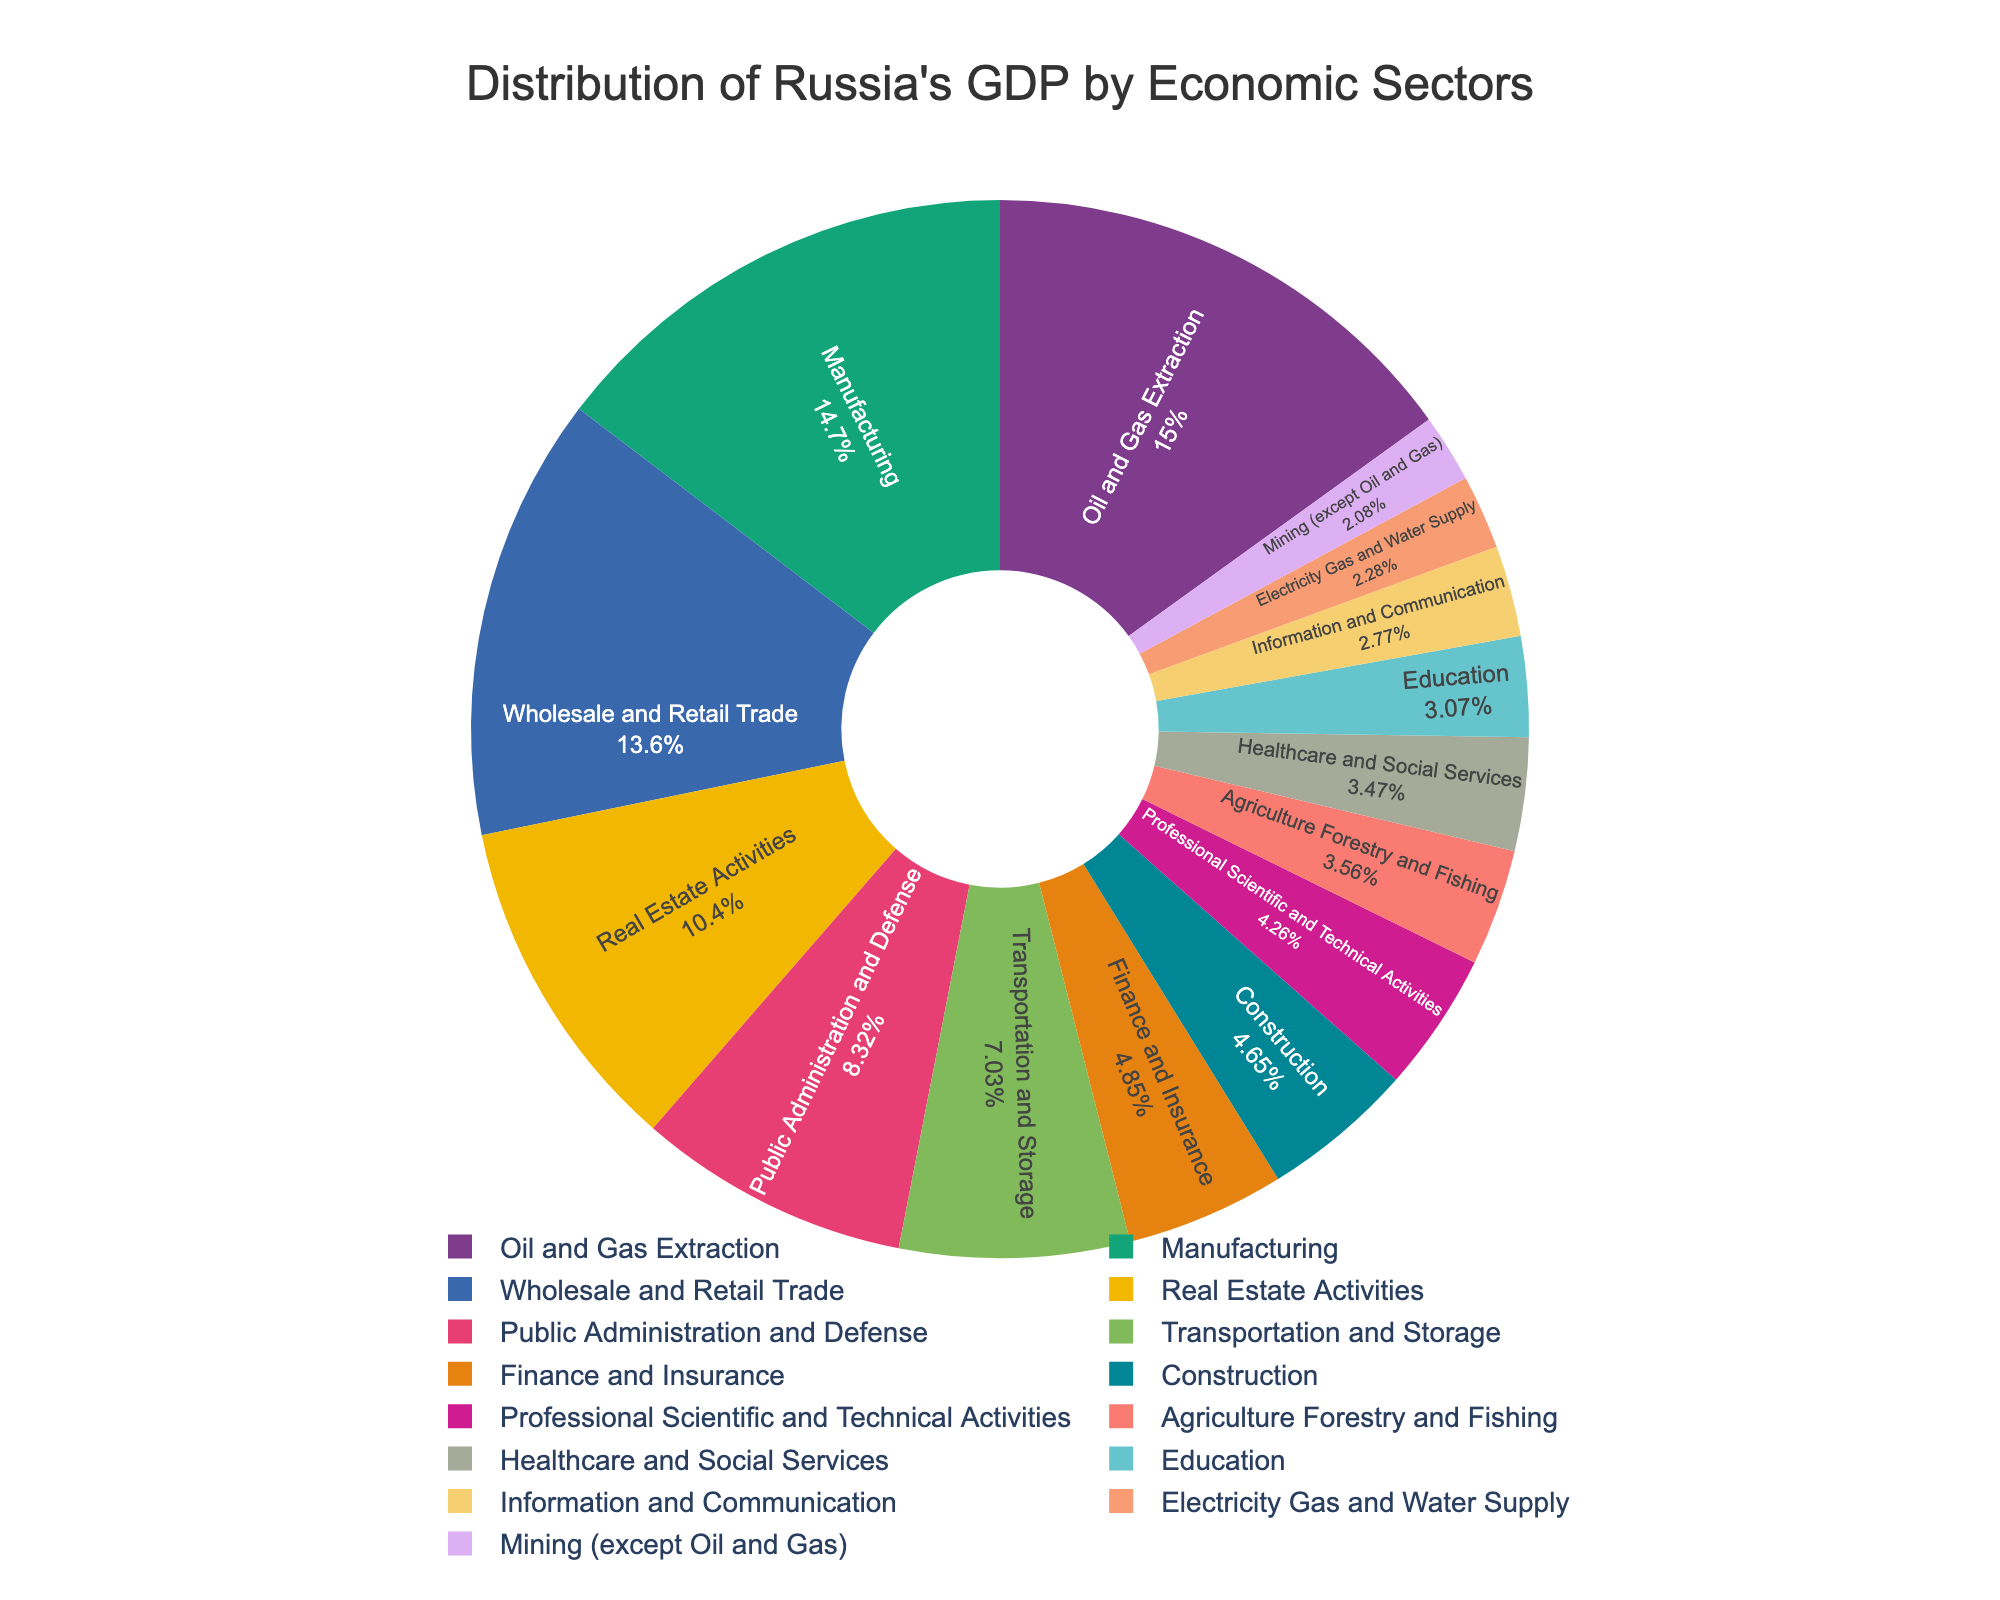Which economic sector has the largest contribution to Russia's GDP? The largest segment in the pie chart represents the sector with the highest percentage. In this case, Oil and Gas Extraction is 15.2%, the highest.
Answer: Oil and Gas Extraction Which two sectors together contribute approximately 28.9% to Russia's GDP? Adding the individual contributions of Manufacturing (14.8%) and Wholesale and Retail Trade (13.7%) results in approximately 28.5%.
Answer: Manufacturing and Wholesale and Retail Trade How much more does Oil and Gas Extraction contribute to GDP compared to Professional Scientific and Technical Activities? Subtract the contribution of Professional Scientific and Technical Activities (4.3%) from the contribution of Oil and Gas Extraction (15.2%): 15.2% - 4.3% = 10.9%.
Answer: 10.9% If you were to combine the contributions of Healthcare and Social Services and Agriculture Forestry and Fishing, how would they compare to the contribution of Real Estate Activities? Add the contributions of Healthcare and Social Services (3.5%) and Agriculture Forestry and Fishing (3.6%), which equals 7.1%, and compare it to Real Estate Activities (10.5%). 7.1% < 10.5%.
Answer: Less than Real Estate Activities Rank the top three sectors in terms of their contribution to Russia’s GDP. By descending order of percentage, the top three sectors are: 1. Oil and Gas Extraction (15.2%), 2. Manufacturing (14.8%), and 3. Wholesale and Retail Trade (13.7%).
Answer: Oil and Gas Extraction, Manufacturing, Wholesale and Retail Trade Which sector contributes the least to Russia's GDP, and what is its contribution? The smallest segment in the pie chart indicates the sector with the lowest percentage. Mining (except Oil and Gas) contributes 2.1%.
Answer: Mining (except Oil and Gas), 2.1% Is the combined contribution of Public Administration and Defense, Transportation and Storage, Finance and Insurance greater than 20%? Sum their contributions: Public Administration and Defense (8.4%) + Transportation and Storage (7.1%) + Finance and Insurance (4.9%) = 20.4%.
Answer: Yes What is the difference in GDP contribution between the sector with the highest percentage and the sector with the lowest percentage? Subtract the contribution of Mining (except Oil and Gas) (2.1%) from the contribution of Oil and Gas Extraction (15.2%): 15.2% - 2.1% = 13.1%.
Answer: 13.1% What is the combined contribution of sectors contributing less than 5% to Russia's GDP? Sum the contributions of sectors with less than 5%: Finance and Insurance (4.9%) + Construction (4.7%) + Professional Scientific and Technical Activities (4.3%) + Education (3.1%) + Healthcare and Social Services (3.5%) + Mining (except Oil and Gas) (2.1%) + Electricity Gas and Water Supply (2.3%) + Information and Communication (2.8%) = 27.7%.
Answer: 27.7% 